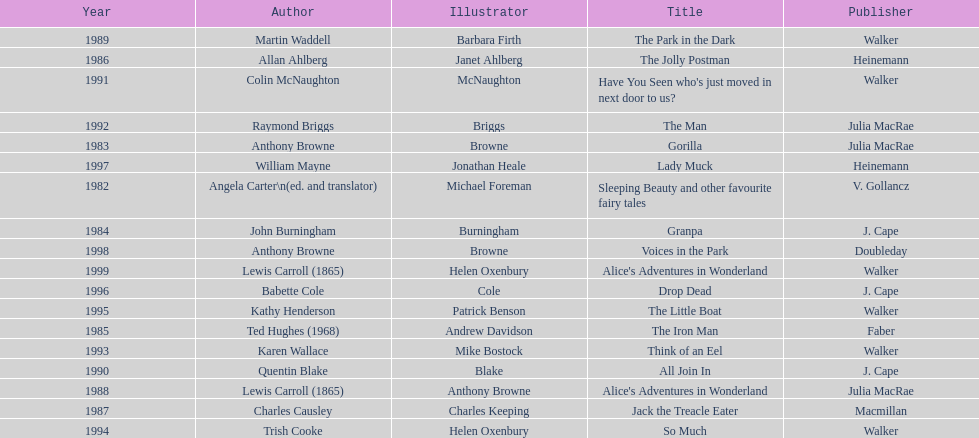Which author composed the foremost award-winning piece? Angela Carter. 